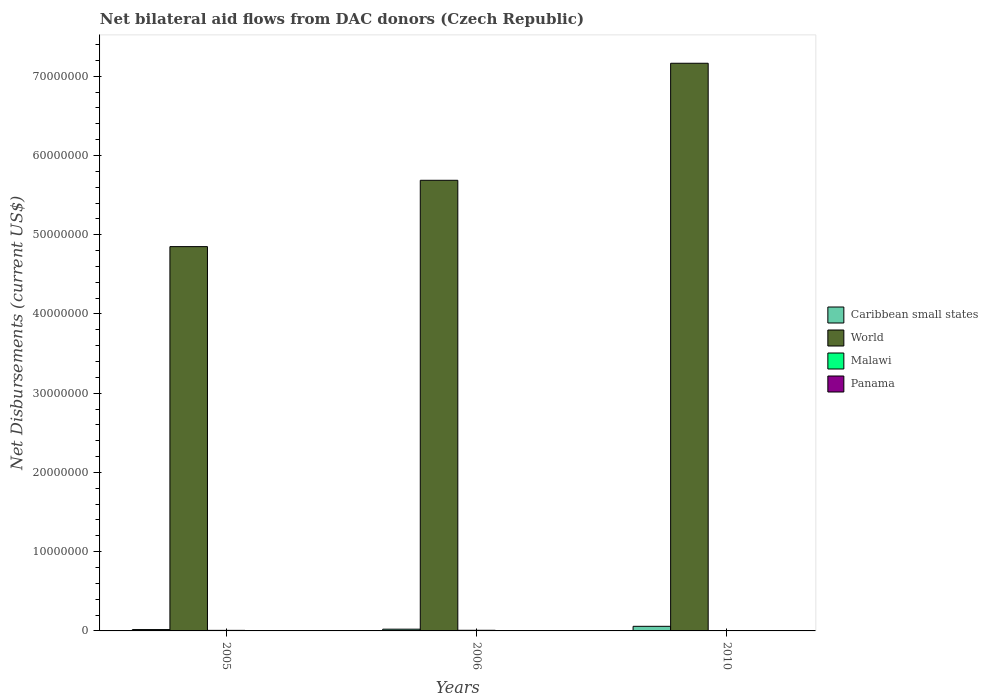How many different coloured bars are there?
Your response must be concise. 4. Are the number of bars per tick equal to the number of legend labels?
Your response must be concise. Yes. How many bars are there on the 2nd tick from the left?
Provide a short and direct response. 4. What is the label of the 2nd group of bars from the left?
Give a very brief answer. 2006. Across all years, what is the maximum net bilateral aid flows in Caribbean small states?
Make the answer very short. 5.80e+05. Across all years, what is the minimum net bilateral aid flows in Caribbean small states?
Keep it short and to the point. 1.70e+05. What is the difference between the net bilateral aid flows in Panama in 2010 and the net bilateral aid flows in World in 2006?
Your answer should be compact. -5.68e+07. What is the average net bilateral aid flows in Panama per year?
Offer a terse response. 1.67e+04. In the year 2010, what is the difference between the net bilateral aid flows in Malawi and net bilateral aid flows in World?
Keep it short and to the point. -7.16e+07. What is the ratio of the net bilateral aid flows in Panama in 2005 to that in 2006?
Keep it short and to the point. 1. Is the net bilateral aid flows in Caribbean small states in 2005 less than that in 2006?
Make the answer very short. Yes. What is the difference between the highest and the second highest net bilateral aid flows in Caribbean small states?
Provide a succinct answer. 3.60e+05. What is the difference between the highest and the lowest net bilateral aid flows in Caribbean small states?
Ensure brevity in your answer.  4.10e+05. In how many years, is the net bilateral aid flows in World greater than the average net bilateral aid flows in World taken over all years?
Ensure brevity in your answer.  1. What does the 1st bar from the left in 2006 represents?
Make the answer very short. Caribbean small states. How many bars are there?
Provide a succinct answer. 12. Are all the bars in the graph horizontal?
Ensure brevity in your answer.  No. How many years are there in the graph?
Give a very brief answer. 3. Are the values on the major ticks of Y-axis written in scientific E-notation?
Your response must be concise. No. Does the graph contain any zero values?
Your answer should be very brief. No. Where does the legend appear in the graph?
Keep it short and to the point. Center right. How many legend labels are there?
Your response must be concise. 4. How are the legend labels stacked?
Offer a very short reply. Vertical. What is the title of the graph?
Keep it short and to the point. Net bilateral aid flows from DAC donors (Czech Republic). What is the label or title of the Y-axis?
Offer a very short reply. Net Disbursements (current US$). What is the Net Disbursements (current US$) in World in 2005?
Ensure brevity in your answer.  4.85e+07. What is the Net Disbursements (current US$) in Caribbean small states in 2006?
Offer a terse response. 2.20e+05. What is the Net Disbursements (current US$) in World in 2006?
Offer a very short reply. 5.69e+07. What is the Net Disbursements (current US$) in Malawi in 2006?
Give a very brief answer. 8.00e+04. What is the Net Disbursements (current US$) of Caribbean small states in 2010?
Your response must be concise. 5.80e+05. What is the Net Disbursements (current US$) in World in 2010?
Provide a short and direct response. 7.16e+07. What is the Net Disbursements (current US$) in Malawi in 2010?
Offer a very short reply. 5.00e+04. What is the Net Disbursements (current US$) in Panama in 2010?
Your answer should be very brief. 3.00e+04. Across all years, what is the maximum Net Disbursements (current US$) in Caribbean small states?
Your answer should be compact. 5.80e+05. Across all years, what is the maximum Net Disbursements (current US$) of World?
Your answer should be very brief. 7.16e+07. Across all years, what is the maximum Net Disbursements (current US$) in Malawi?
Offer a terse response. 8.00e+04. Across all years, what is the maximum Net Disbursements (current US$) in Panama?
Your answer should be very brief. 3.00e+04. Across all years, what is the minimum Net Disbursements (current US$) of World?
Keep it short and to the point. 4.85e+07. Across all years, what is the minimum Net Disbursements (current US$) in Panama?
Make the answer very short. 10000. What is the total Net Disbursements (current US$) of Caribbean small states in the graph?
Provide a short and direct response. 9.70e+05. What is the total Net Disbursements (current US$) of World in the graph?
Ensure brevity in your answer.  1.77e+08. What is the difference between the Net Disbursements (current US$) in World in 2005 and that in 2006?
Your answer should be compact. -8.37e+06. What is the difference between the Net Disbursements (current US$) of Panama in 2005 and that in 2006?
Your answer should be compact. 0. What is the difference between the Net Disbursements (current US$) in Caribbean small states in 2005 and that in 2010?
Make the answer very short. -4.10e+05. What is the difference between the Net Disbursements (current US$) in World in 2005 and that in 2010?
Your answer should be very brief. -2.31e+07. What is the difference between the Net Disbursements (current US$) of Caribbean small states in 2006 and that in 2010?
Your answer should be compact. -3.60e+05. What is the difference between the Net Disbursements (current US$) in World in 2006 and that in 2010?
Provide a short and direct response. -1.48e+07. What is the difference between the Net Disbursements (current US$) of Malawi in 2006 and that in 2010?
Your response must be concise. 3.00e+04. What is the difference between the Net Disbursements (current US$) of Caribbean small states in 2005 and the Net Disbursements (current US$) of World in 2006?
Make the answer very short. -5.67e+07. What is the difference between the Net Disbursements (current US$) of Caribbean small states in 2005 and the Net Disbursements (current US$) of Malawi in 2006?
Give a very brief answer. 9.00e+04. What is the difference between the Net Disbursements (current US$) of Caribbean small states in 2005 and the Net Disbursements (current US$) of Panama in 2006?
Your answer should be compact. 1.60e+05. What is the difference between the Net Disbursements (current US$) of World in 2005 and the Net Disbursements (current US$) of Malawi in 2006?
Your answer should be compact. 4.84e+07. What is the difference between the Net Disbursements (current US$) of World in 2005 and the Net Disbursements (current US$) of Panama in 2006?
Keep it short and to the point. 4.85e+07. What is the difference between the Net Disbursements (current US$) in Caribbean small states in 2005 and the Net Disbursements (current US$) in World in 2010?
Ensure brevity in your answer.  -7.15e+07. What is the difference between the Net Disbursements (current US$) in Caribbean small states in 2005 and the Net Disbursements (current US$) in Panama in 2010?
Your answer should be compact. 1.40e+05. What is the difference between the Net Disbursements (current US$) of World in 2005 and the Net Disbursements (current US$) of Malawi in 2010?
Your answer should be compact. 4.84e+07. What is the difference between the Net Disbursements (current US$) of World in 2005 and the Net Disbursements (current US$) of Panama in 2010?
Offer a very short reply. 4.85e+07. What is the difference between the Net Disbursements (current US$) in Malawi in 2005 and the Net Disbursements (current US$) in Panama in 2010?
Your answer should be compact. 4.00e+04. What is the difference between the Net Disbursements (current US$) in Caribbean small states in 2006 and the Net Disbursements (current US$) in World in 2010?
Your answer should be very brief. -7.14e+07. What is the difference between the Net Disbursements (current US$) in Caribbean small states in 2006 and the Net Disbursements (current US$) in Panama in 2010?
Ensure brevity in your answer.  1.90e+05. What is the difference between the Net Disbursements (current US$) of World in 2006 and the Net Disbursements (current US$) of Malawi in 2010?
Provide a succinct answer. 5.68e+07. What is the difference between the Net Disbursements (current US$) in World in 2006 and the Net Disbursements (current US$) in Panama in 2010?
Your response must be concise. 5.68e+07. What is the average Net Disbursements (current US$) in Caribbean small states per year?
Give a very brief answer. 3.23e+05. What is the average Net Disbursements (current US$) in World per year?
Provide a short and direct response. 5.90e+07. What is the average Net Disbursements (current US$) in Malawi per year?
Your answer should be very brief. 6.67e+04. What is the average Net Disbursements (current US$) in Panama per year?
Your answer should be compact. 1.67e+04. In the year 2005, what is the difference between the Net Disbursements (current US$) of Caribbean small states and Net Disbursements (current US$) of World?
Offer a very short reply. -4.83e+07. In the year 2005, what is the difference between the Net Disbursements (current US$) in Caribbean small states and Net Disbursements (current US$) in Malawi?
Your answer should be very brief. 1.00e+05. In the year 2005, what is the difference between the Net Disbursements (current US$) in World and Net Disbursements (current US$) in Malawi?
Keep it short and to the point. 4.84e+07. In the year 2005, what is the difference between the Net Disbursements (current US$) in World and Net Disbursements (current US$) in Panama?
Your response must be concise. 4.85e+07. In the year 2005, what is the difference between the Net Disbursements (current US$) in Malawi and Net Disbursements (current US$) in Panama?
Make the answer very short. 6.00e+04. In the year 2006, what is the difference between the Net Disbursements (current US$) in Caribbean small states and Net Disbursements (current US$) in World?
Provide a short and direct response. -5.66e+07. In the year 2006, what is the difference between the Net Disbursements (current US$) of Caribbean small states and Net Disbursements (current US$) of Malawi?
Offer a terse response. 1.40e+05. In the year 2006, what is the difference between the Net Disbursements (current US$) of World and Net Disbursements (current US$) of Malawi?
Keep it short and to the point. 5.68e+07. In the year 2006, what is the difference between the Net Disbursements (current US$) of World and Net Disbursements (current US$) of Panama?
Your response must be concise. 5.69e+07. In the year 2010, what is the difference between the Net Disbursements (current US$) in Caribbean small states and Net Disbursements (current US$) in World?
Provide a succinct answer. -7.11e+07. In the year 2010, what is the difference between the Net Disbursements (current US$) of Caribbean small states and Net Disbursements (current US$) of Malawi?
Your response must be concise. 5.30e+05. In the year 2010, what is the difference between the Net Disbursements (current US$) of Caribbean small states and Net Disbursements (current US$) of Panama?
Provide a short and direct response. 5.50e+05. In the year 2010, what is the difference between the Net Disbursements (current US$) in World and Net Disbursements (current US$) in Malawi?
Your response must be concise. 7.16e+07. In the year 2010, what is the difference between the Net Disbursements (current US$) of World and Net Disbursements (current US$) of Panama?
Offer a terse response. 7.16e+07. In the year 2010, what is the difference between the Net Disbursements (current US$) of Malawi and Net Disbursements (current US$) of Panama?
Offer a very short reply. 2.00e+04. What is the ratio of the Net Disbursements (current US$) of Caribbean small states in 2005 to that in 2006?
Offer a terse response. 0.77. What is the ratio of the Net Disbursements (current US$) in World in 2005 to that in 2006?
Make the answer very short. 0.85. What is the ratio of the Net Disbursements (current US$) in Malawi in 2005 to that in 2006?
Offer a terse response. 0.88. What is the ratio of the Net Disbursements (current US$) of Caribbean small states in 2005 to that in 2010?
Offer a terse response. 0.29. What is the ratio of the Net Disbursements (current US$) of World in 2005 to that in 2010?
Make the answer very short. 0.68. What is the ratio of the Net Disbursements (current US$) of Panama in 2005 to that in 2010?
Offer a terse response. 0.33. What is the ratio of the Net Disbursements (current US$) in Caribbean small states in 2006 to that in 2010?
Provide a succinct answer. 0.38. What is the ratio of the Net Disbursements (current US$) in World in 2006 to that in 2010?
Offer a very short reply. 0.79. What is the ratio of the Net Disbursements (current US$) in Panama in 2006 to that in 2010?
Your answer should be compact. 0.33. What is the difference between the highest and the second highest Net Disbursements (current US$) in World?
Offer a terse response. 1.48e+07. What is the difference between the highest and the second highest Net Disbursements (current US$) in Malawi?
Offer a terse response. 10000. What is the difference between the highest and the lowest Net Disbursements (current US$) of Caribbean small states?
Keep it short and to the point. 4.10e+05. What is the difference between the highest and the lowest Net Disbursements (current US$) of World?
Ensure brevity in your answer.  2.31e+07. 